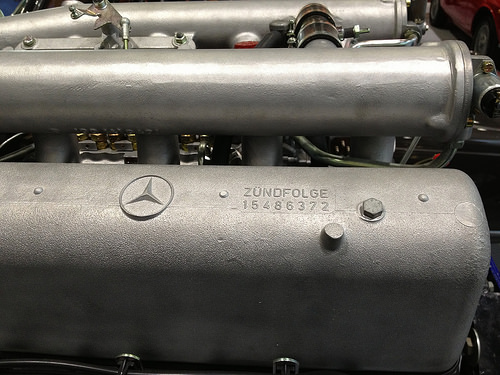<image>
Can you confirm if the loco is on the steel? Yes. Looking at the image, I can see the loco is positioned on top of the steel, with the steel providing support. 